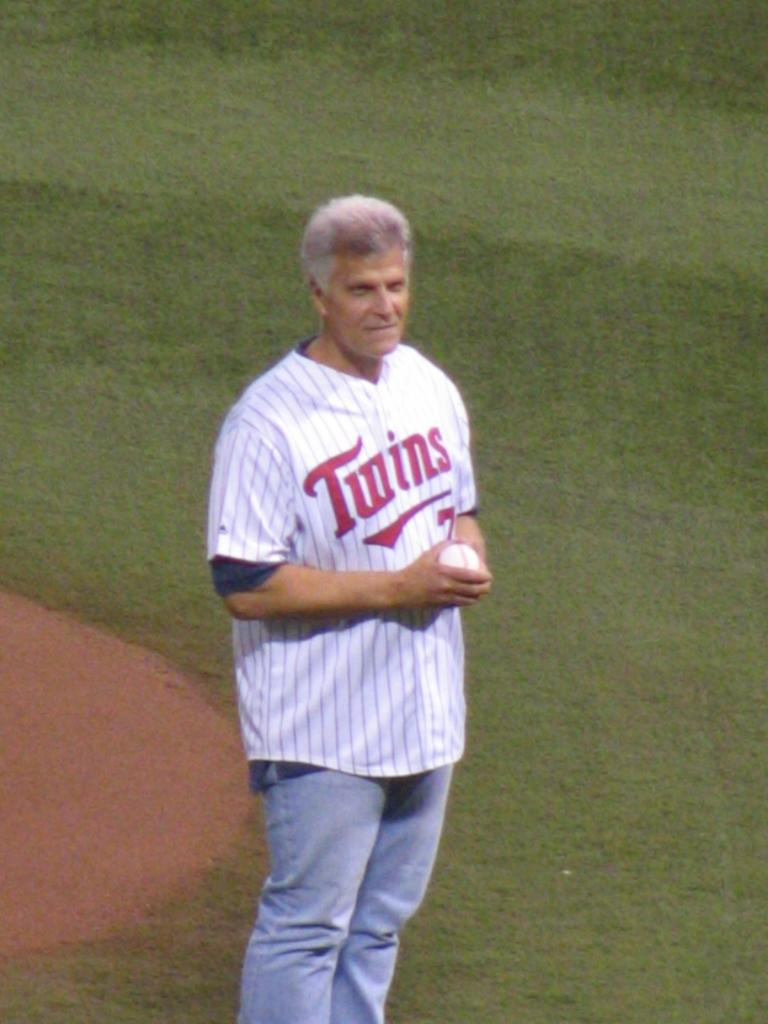<image>
Offer a succinct explanation of the picture presented. A man wearing a Twins jersey stands out in the field holding a baseball. 